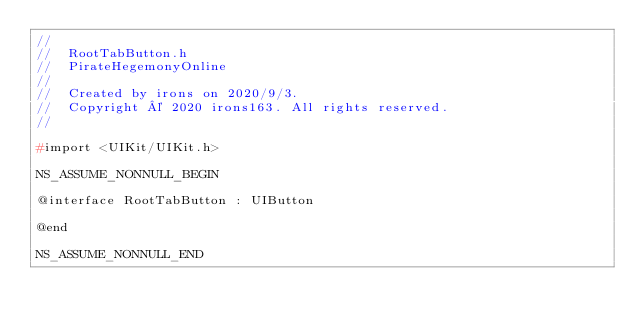<code> <loc_0><loc_0><loc_500><loc_500><_C_>//
//  RootTabButton.h
//  PirateHegemonyOnline
//
//  Created by irons on 2020/9/3.
//  Copyright © 2020 irons163. All rights reserved.
//

#import <UIKit/UIKit.h>

NS_ASSUME_NONNULL_BEGIN

@interface RootTabButton : UIButton

@end

NS_ASSUME_NONNULL_END
</code> 